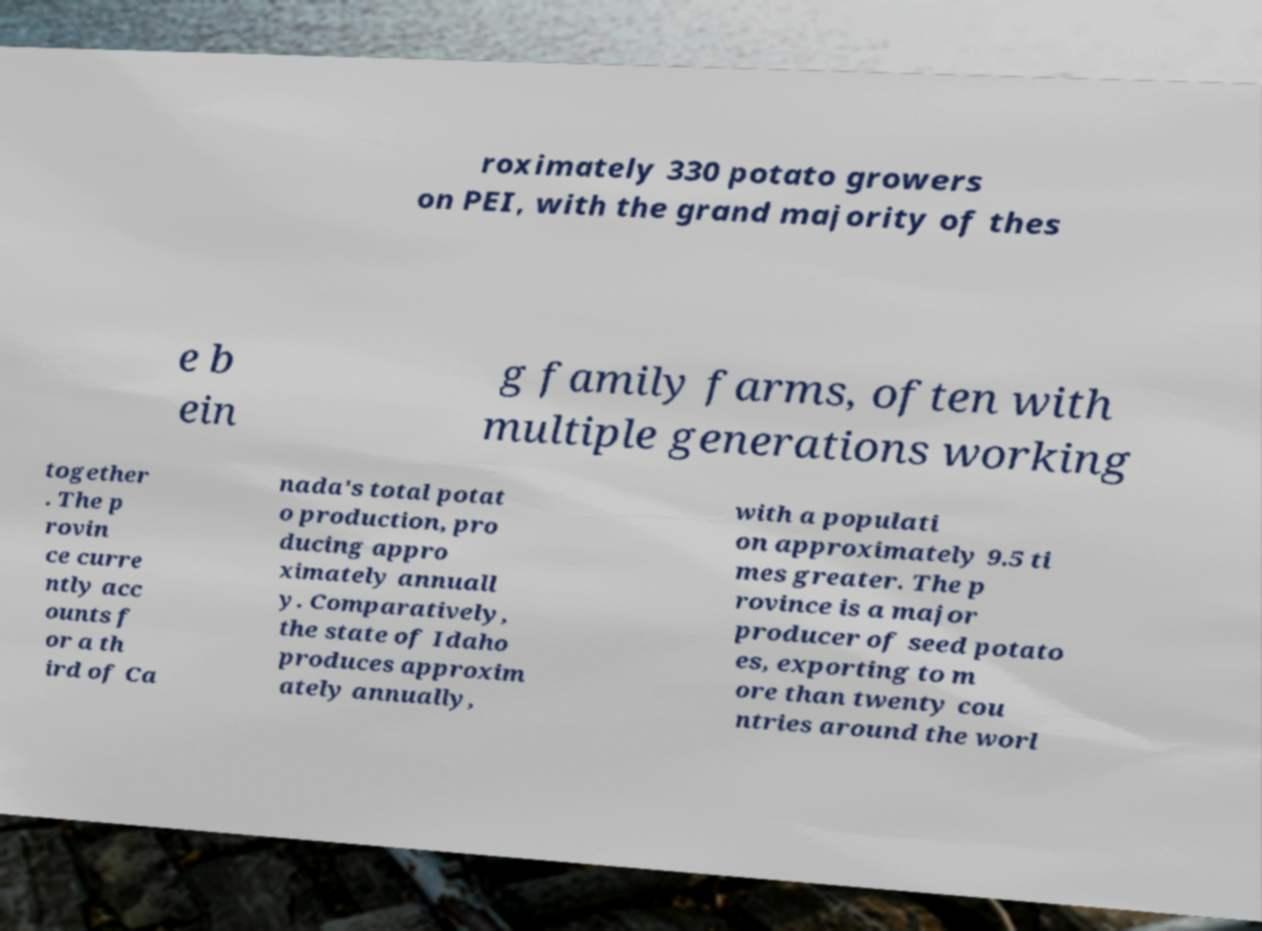I need the written content from this picture converted into text. Can you do that? roximately 330 potato growers on PEI, with the grand majority of thes e b ein g family farms, often with multiple generations working together . The p rovin ce curre ntly acc ounts f or a th ird of Ca nada's total potat o production, pro ducing appro ximately annuall y. Comparatively, the state of Idaho produces approxim ately annually, with a populati on approximately 9.5 ti mes greater. The p rovince is a major producer of seed potato es, exporting to m ore than twenty cou ntries around the worl 